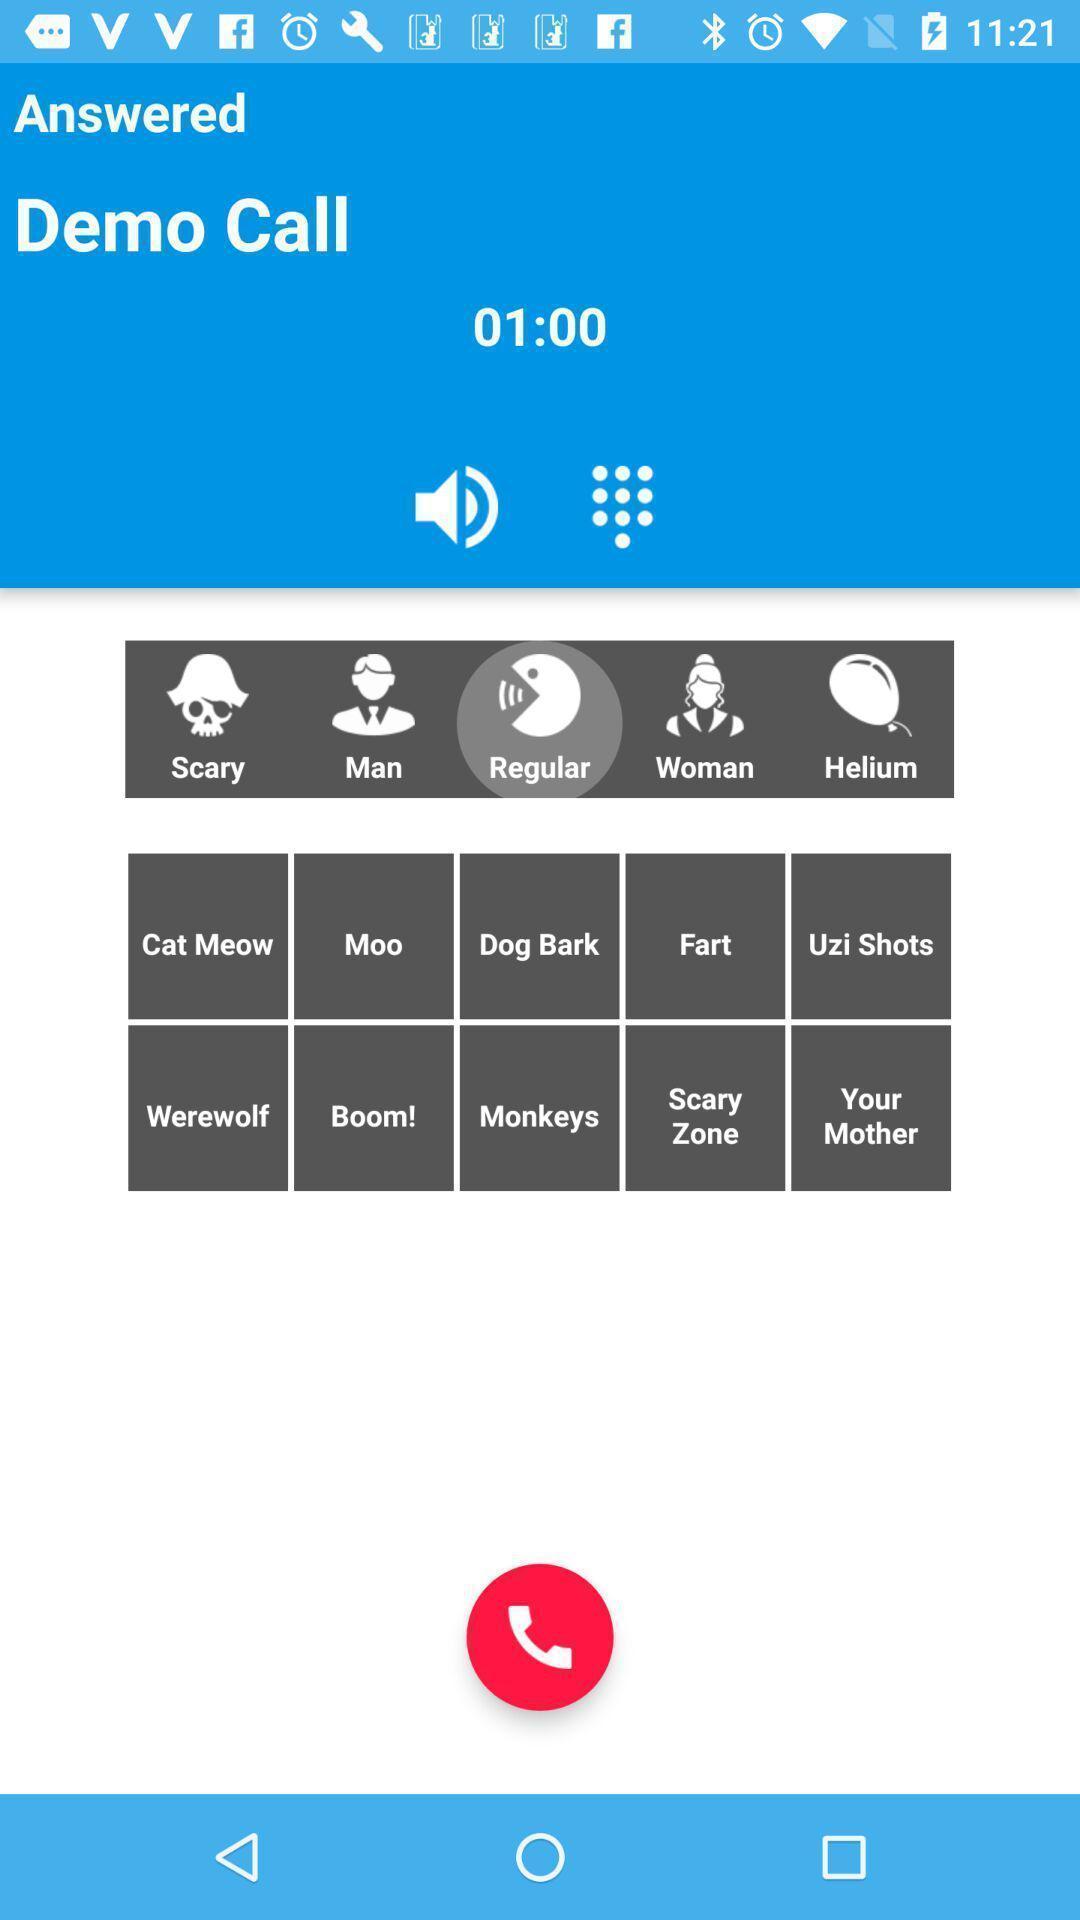Give me a narrative description of this picture. Page displaying information about calling application with many options. 